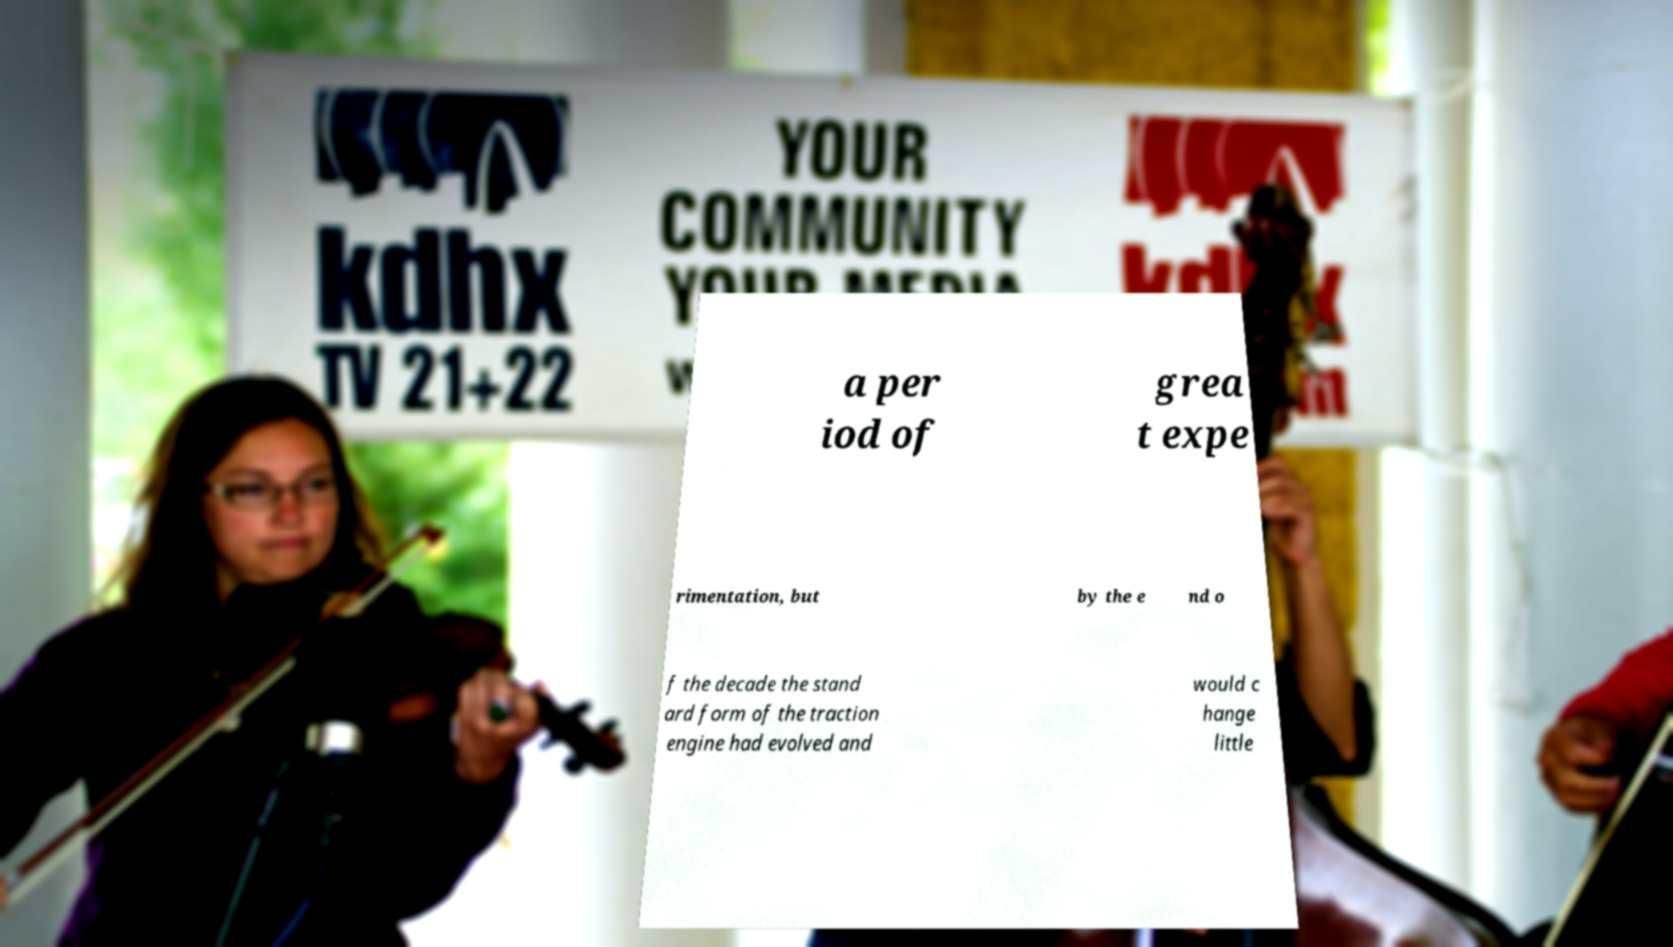Can you accurately transcribe the text from the provided image for me? a per iod of grea t expe rimentation, but by the e nd o f the decade the stand ard form of the traction engine had evolved and would c hange little 